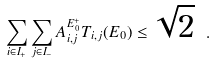Convert formula to latex. <formula><loc_0><loc_0><loc_500><loc_500>\sum _ { i \in I _ { + } } \sum _ { j \in I _ { - } } A ^ { E _ { 0 } ^ { + } } _ { i , j } T _ { i , j } ( E _ { 0 } ) \leq \sqrt { 2 } \ .</formula> 